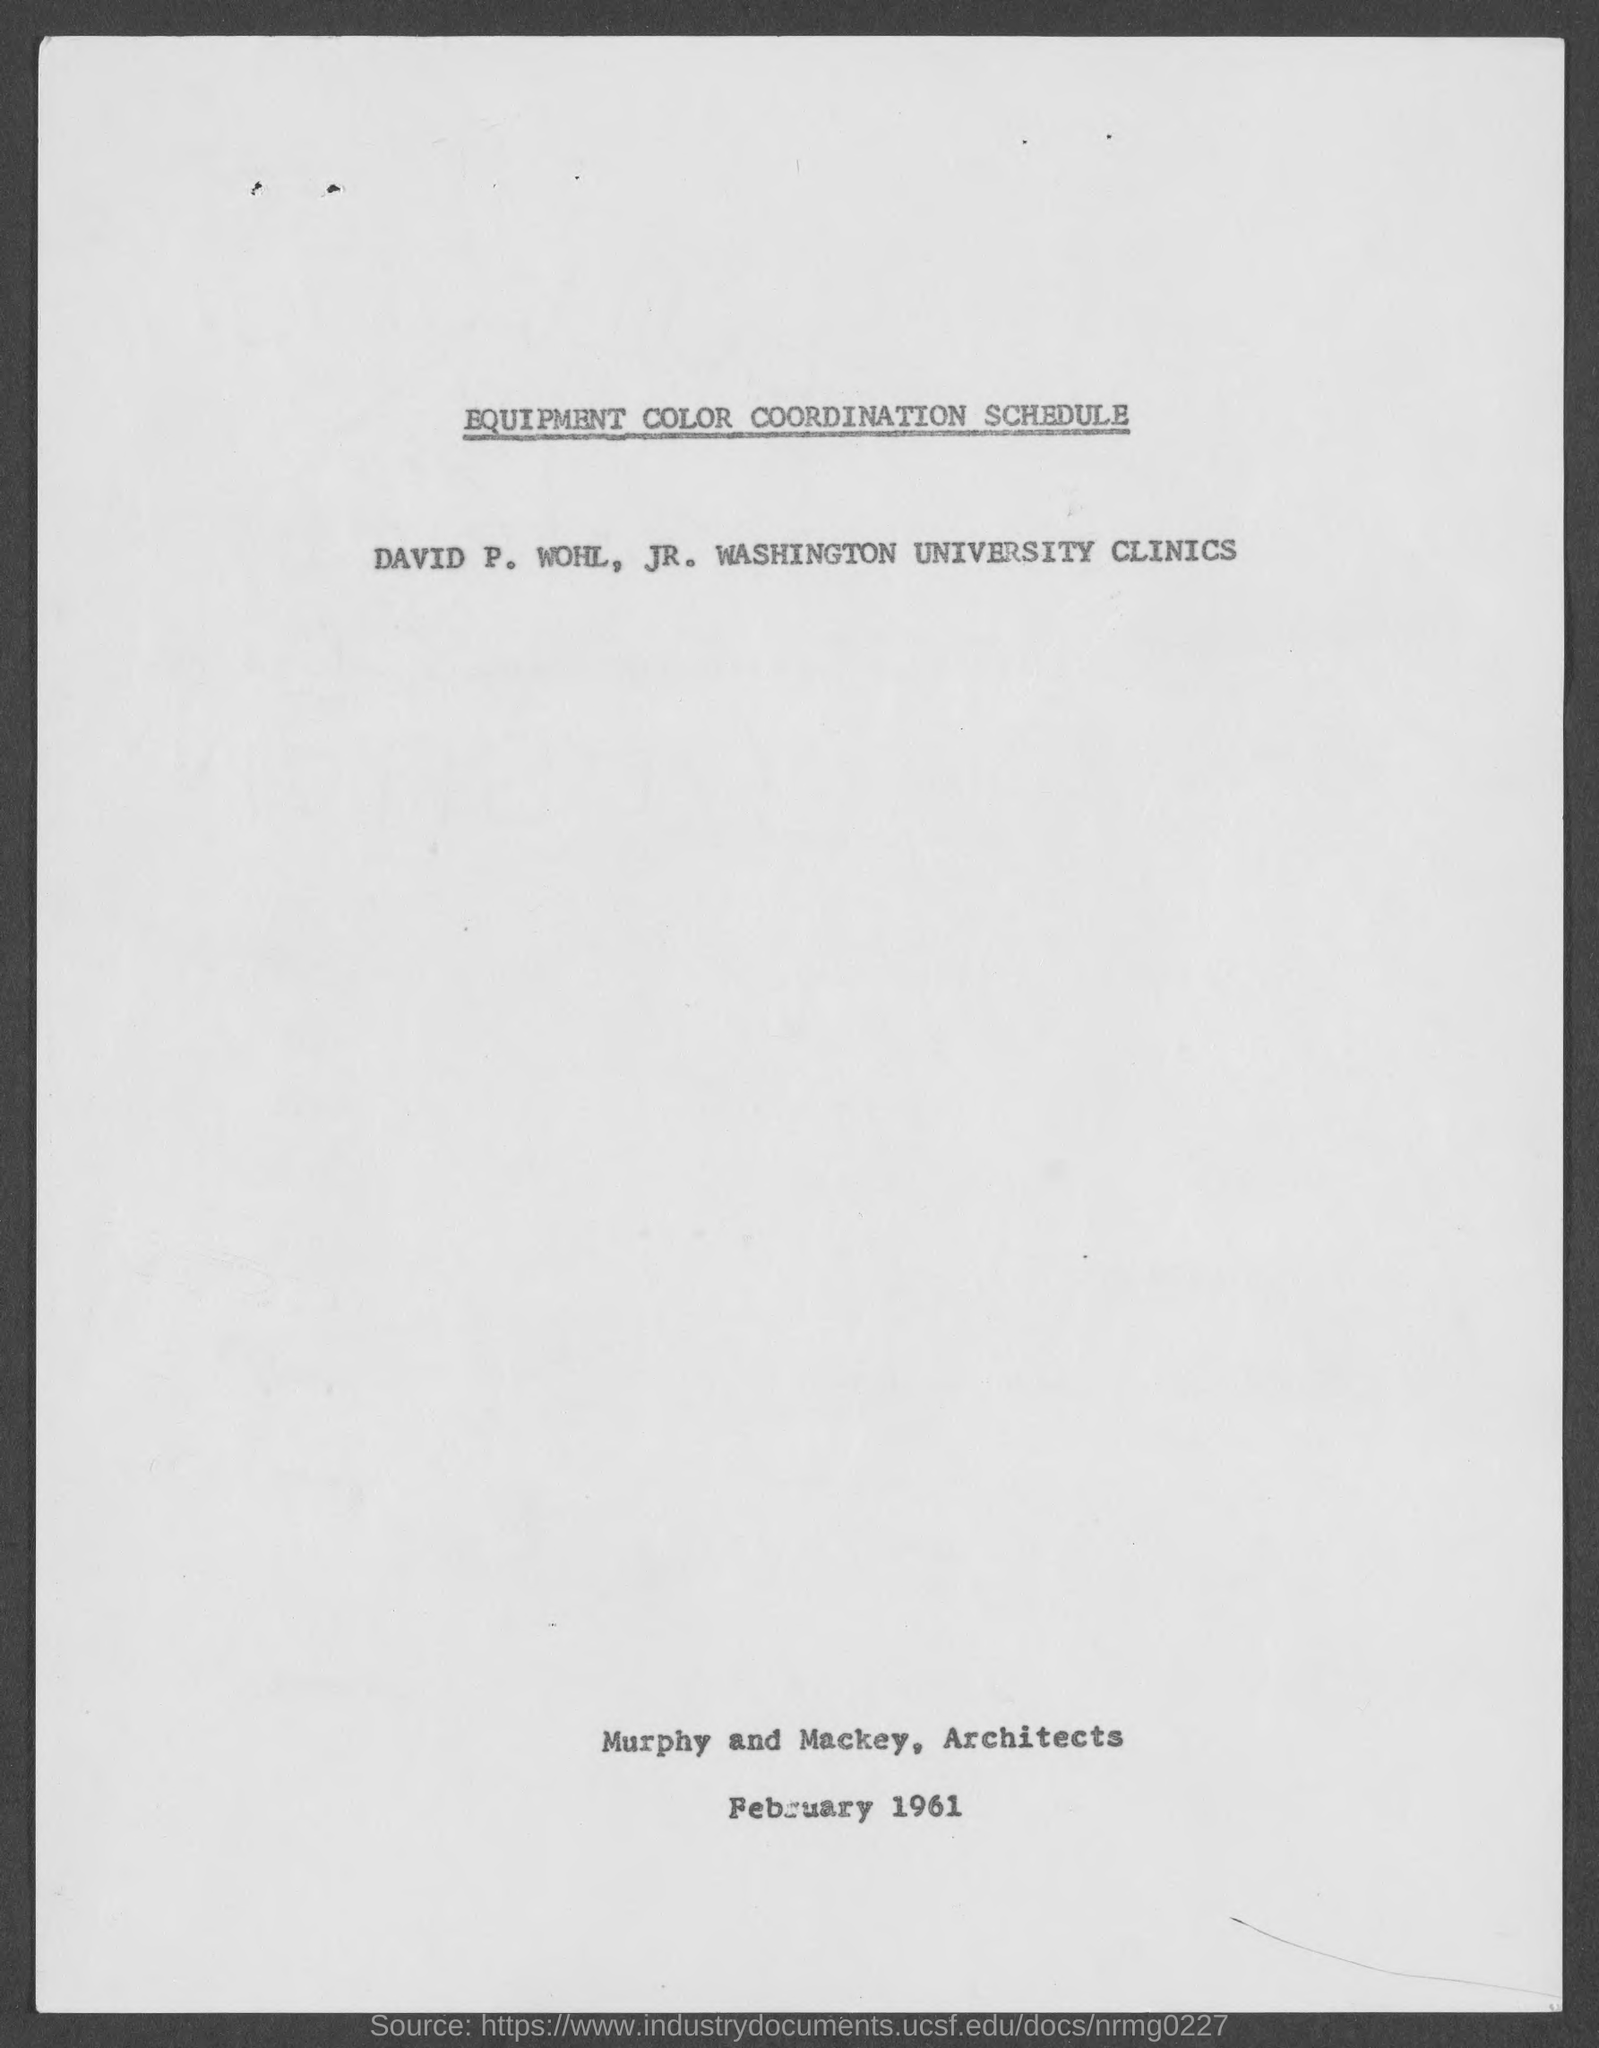Give some essential details in this illustration. The date mentioned is February 1961. Architects named Murphy and Mackey are responsible for the construction of this building. 